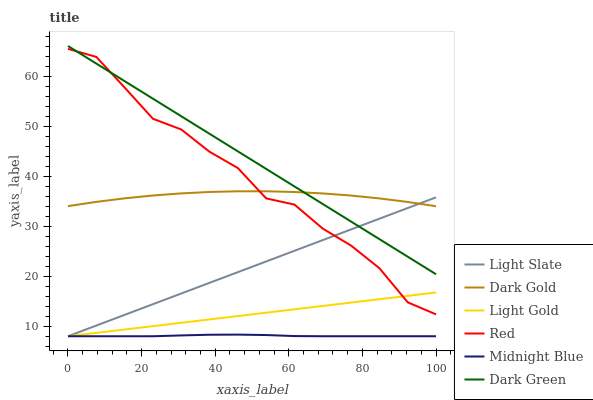Does Midnight Blue have the minimum area under the curve?
Answer yes or no. Yes. Does Dark Green have the maximum area under the curve?
Answer yes or no. Yes. Does Dark Gold have the minimum area under the curve?
Answer yes or no. No. Does Dark Gold have the maximum area under the curve?
Answer yes or no. No. Is Light Gold the smoothest?
Answer yes or no. Yes. Is Red the roughest?
Answer yes or no. Yes. Is Dark Gold the smoothest?
Answer yes or no. No. Is Dark Gold the roughest?
Answer yes or no. No. Does Midnight Blue have the lowest value?
Answer yes or no. Yes. Does Dark Gold have the lowest value?
Answer yes or no. No. Does Dark Green have the highest value?
Answer yes or no. Yes. Does Dark Gold have the highest value?
Answer yes or no. No. Is Midnight Blue less than Dark Gold?
Answer yes or no. Yes. Is Dark Green greater than Midnight Blue?
Answer yes or no. Yes. Does Light Slate intersect Red?
Answer yes or no. Yes. Is Light Slate less than Red?
Answer yes or no. No. Is Light Slate greater than Red?
Answer yes or no. No. Does Midnight Blue intersect Dark Gold?
Answer yes or no. No. 